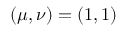<formula> <loc_0><loc_0><loc_500><loc_500>( \mu , \nu ) = ( 1 , 1 )</formula> 